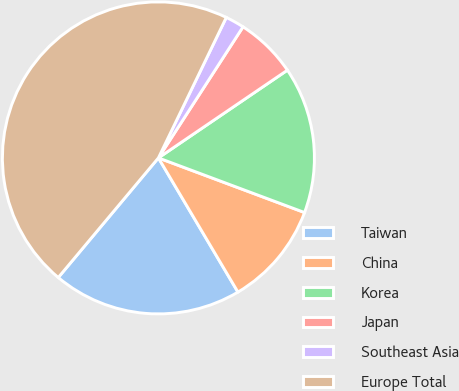Convert chart to OTSL. <chart><loc_0><loc_0><loc_500><loc_500><pie_chart><fcel>Taiwan<fcel>China<fcel>Korea<fcel>Japan<fcel>Southeast Asia<fcel>Europe Total<nl><fcel>19.61%<fcel>10.79%<fcel>15.2%<fcel>6.37%<fcel>1.96%<fcel>46.07%<nl></chart> 